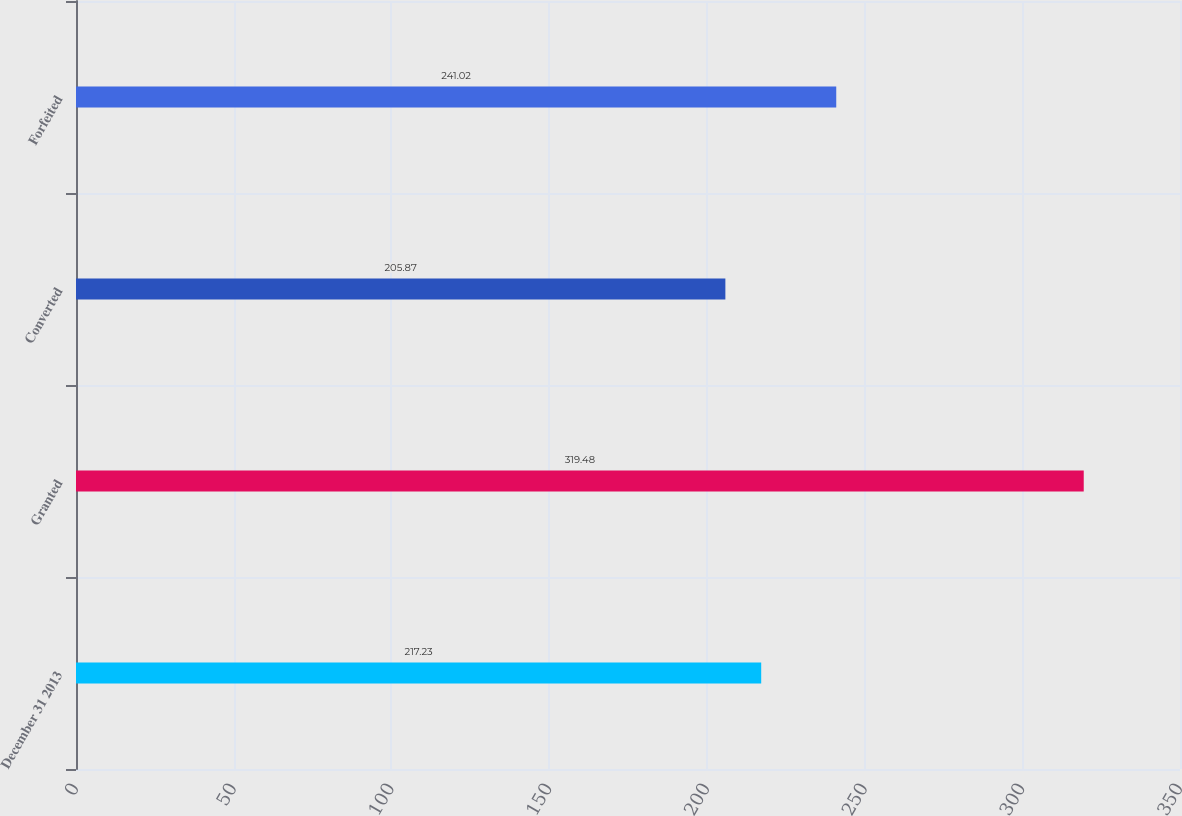Convert chart. <chart><loc_0><loc_0><loc_500><loc_500><bar_chart><fcel>December 31 2013<fcel>Granted<fcel>Converted<fcel>Forfeited<nl><fcel>217.23<fcel>319.48<fcel>205.87<fcel>241.02<nl></chart> 